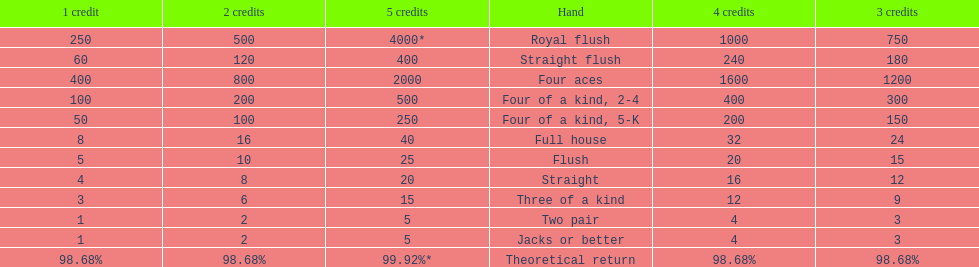What's the best type of four of a kind to win? Four of a kind, 2-4. 